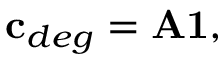<formula> <loc_0><loc_0><loc_500><loc_500>{ c } _ { d e g } = { A 1 } ,</formula> 